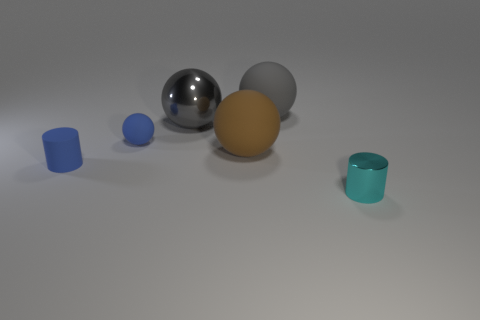Does the tiny cylinder to the left of the gray rubber thing have the same color as the small rubber ball?
Provide a short and direct response. Yes. There is a blue object that is the same shape as the big brown rubber thing; what is it made of?
Your response must be concise. Rubber. Are there more matte things than objects?
Provide a short and direct response. No. There is a big metallic sphere; is its color the same as the big matte sphere that is behind the shiny ball?
Ensure brevity in your answer.  Yes. What is the color of the small object that is both in front of the small blue sphere and on the left side of the small cyan metallic cylinder?
Provide a short and direct response. Blue. How many other things are there of the same material as the large brown ball?
Offer a terse response. 3. Are there fewer metallic things than matte spheres?
Make the answer very short. Yes. Do the small cyan cylinder and the gray sphere behind the shiny sphere have the same material?
Keep it short and to the point. No. There is a big shiny object that is behind the tiny shiny cylinder; what shape is it?
Give a very brief answer. Sphere. Are there any other things that have the same color as the metallic ball?
Keep it short and to the point. Yes. 